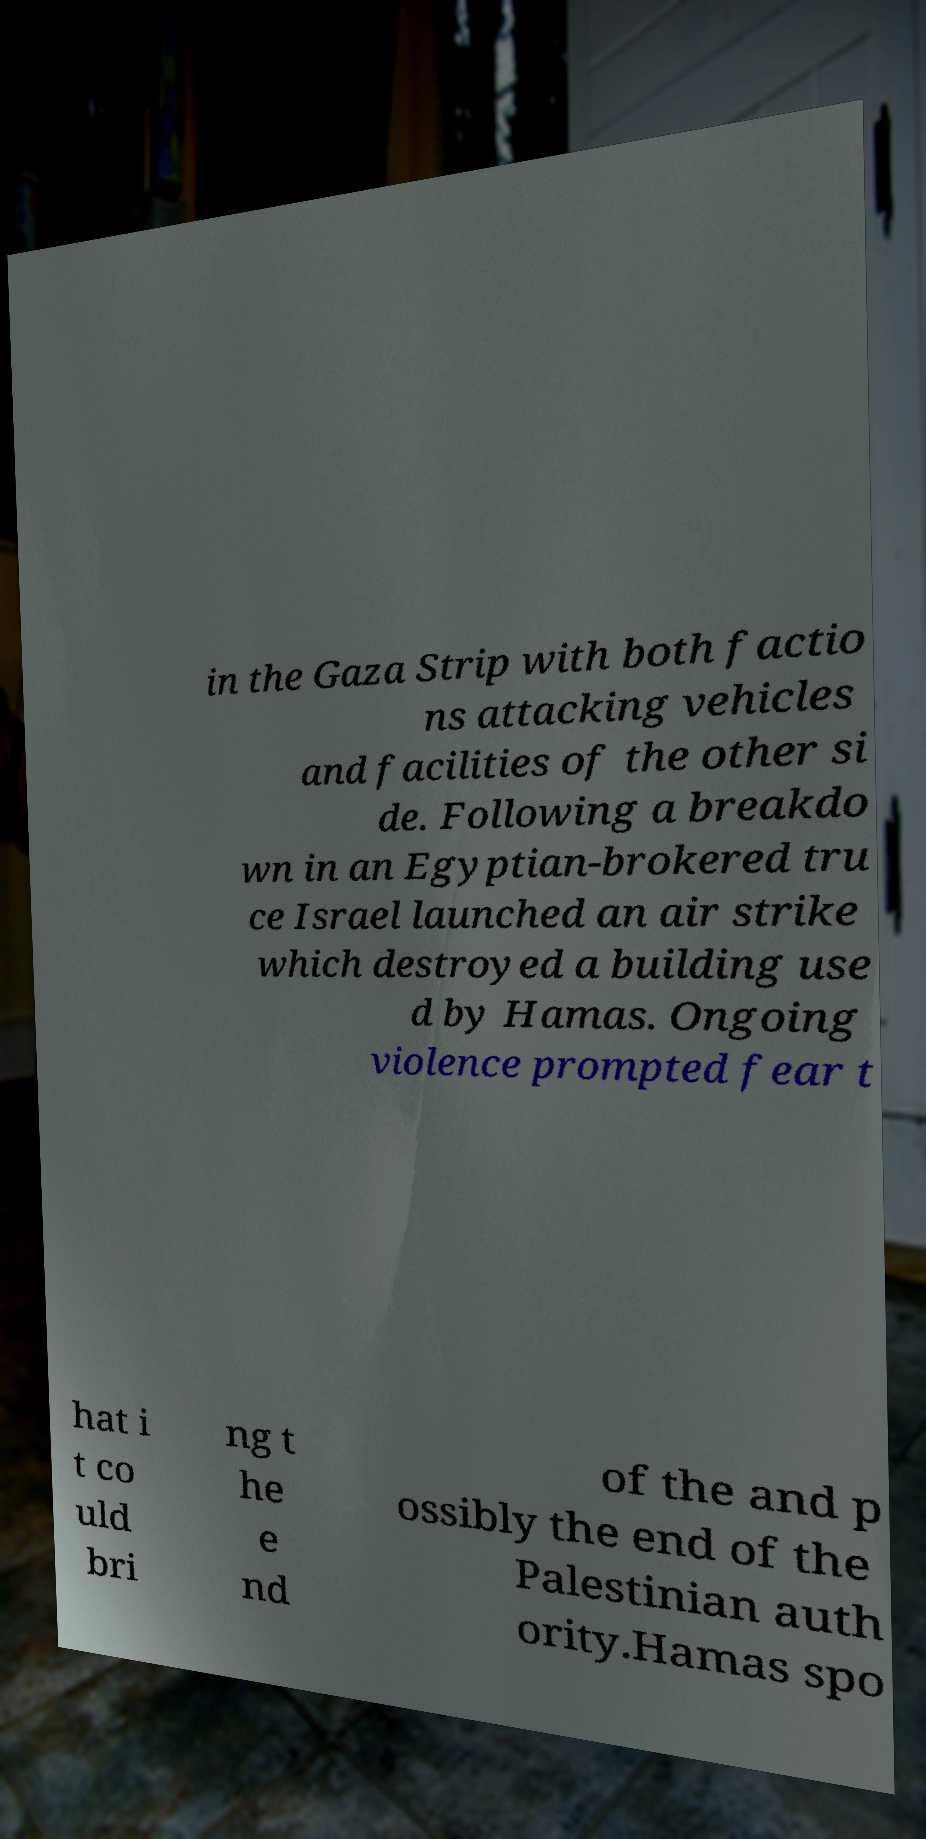Could you assist in decoding the text presented in this image and type it out clearly? in the Gaza Strip with both factio ns attacking vehicles and facilities of the other si de. Following a breakdo wn in an Egyptian-brokered tru ce Israel launched an air strike which destroyed a building use d by Hamas. Ongoing violence prompted fear t hat i t co uld bri ng t he e nd of the and p ossibly the end of the Palestinian auth ority.Hamas spo 